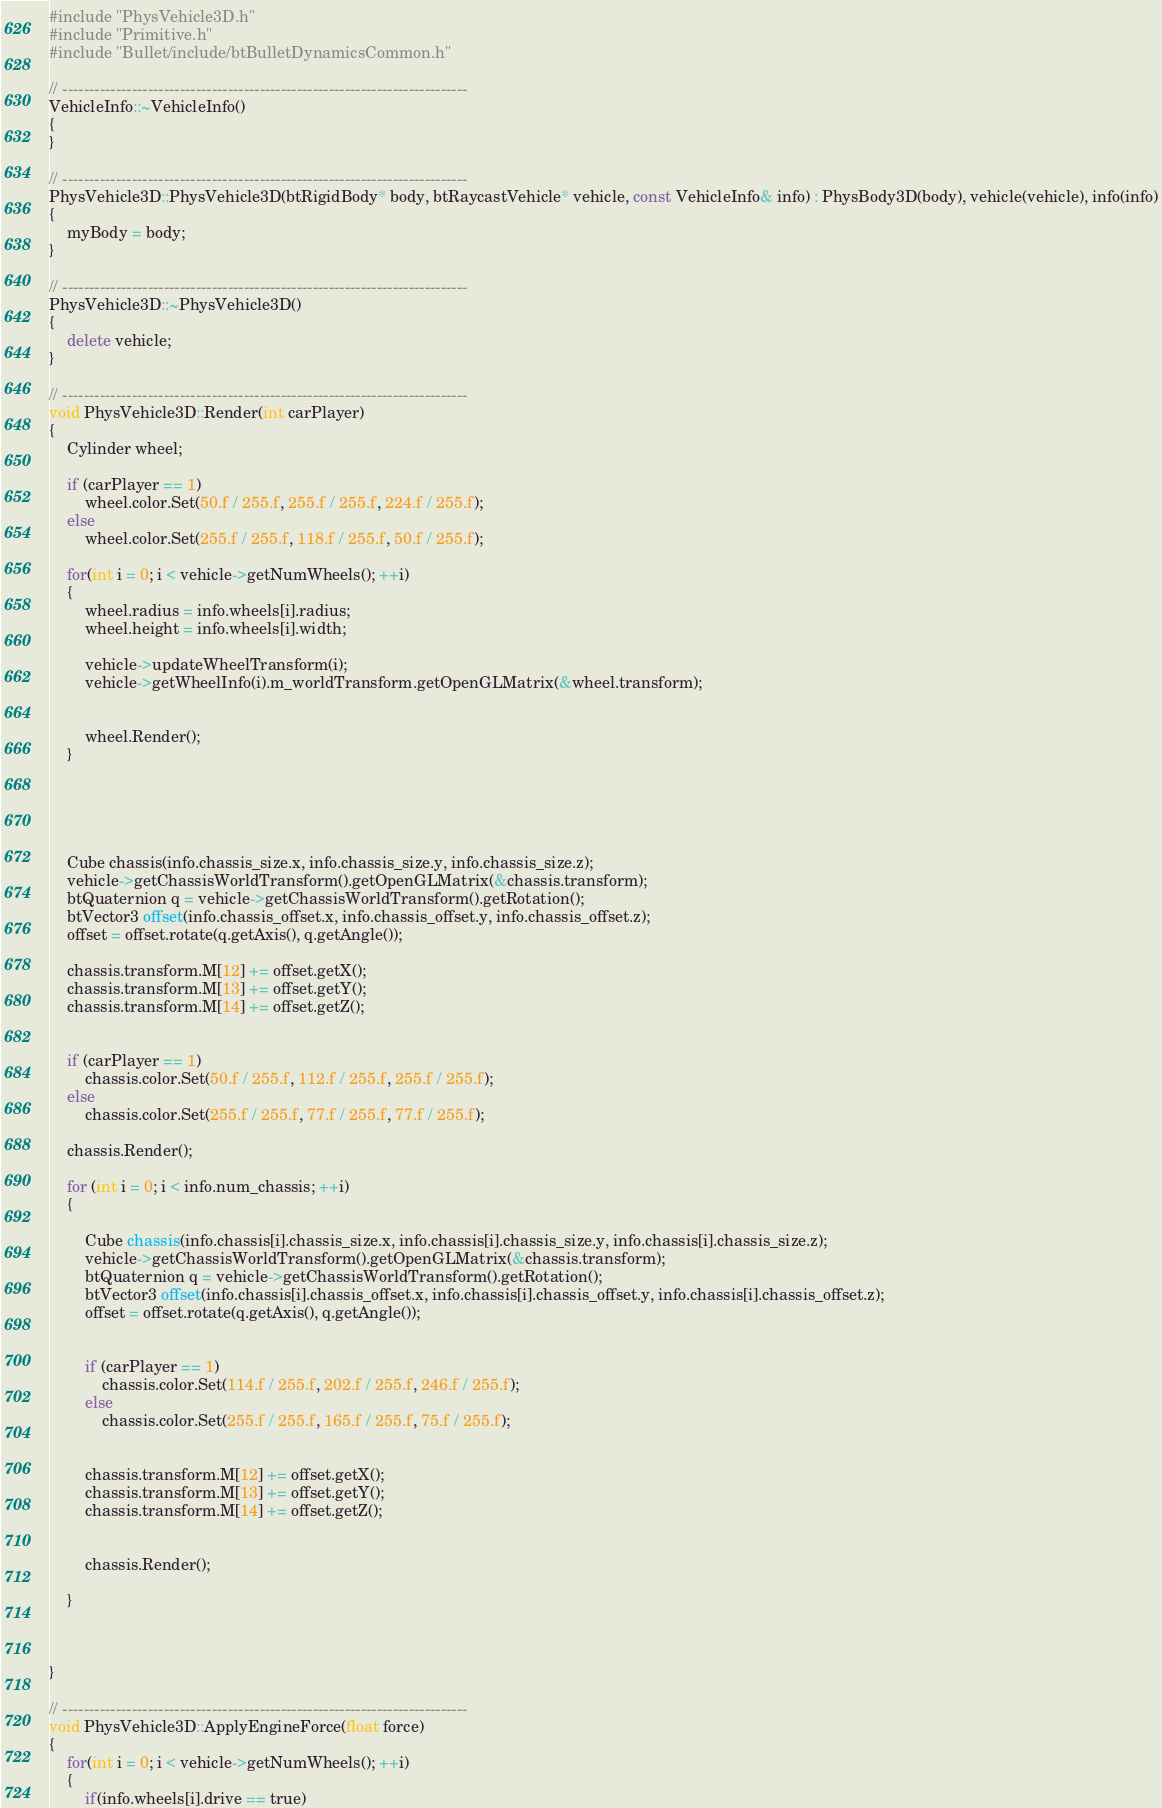Convert code to text. <code><loc_0><loc_0><loc_500><loc_500><_C++_>#include "PhysVehicle3D.h"
#include "Primitive.h"
#include "Bullet/include/btBulletDynamicsCommon.h"

// ----------------------------------------------------------------------------
VehicleInfo::~VehicleInfo()
{	
}

// ----------------------------------------------------------------------------
PhysVehicle3D::PhysVehicle3D(btRigidBody* body, btRaycastVehicle* vehicle, const VehicleInfo& info) : PhysBody3D(body), vehicle(vehicle), info(info)
{
	myBody = body;
}

// ----------------------------------------------------------------------------
PhysVehicle3D::~PhysVehicle3D()
{
	delete vehicle;
}

// ----------------------------------------------------------------------------
void PhysVehicle3D::Render(int carPlayer)
{
	Cylinder wheel;

	if (carPlayer == 1)
		wheel.color.Set(50.f / 255.f, 255.f / 255.f, 224.f / 255.f);
	else
		wheel.color.Set(255.f / 255.f, 118.f / 255.f, 50.f / 255.f);

	for(int i = 0; i < vehicle->getNumWheels(); ++i)
	{
		wheel.radius = info.wheels[i].radius;
		wheel.height = info.wheels[i].width;

		vehicle->updateWheelTransform(i);
		vehicle->getWheelInfo(i).m_worldTransform.getOpenGLMatrix(&wheel.transform);
		
		
		wheel.Render();
	}



		

	Cube chassis(info.chassis_size.x, info.chassis_size.y, info.chassis_size.z);
	vehicle->getChassisWorldTransform().getOpenGLMatrix(&chassis.transform);
	btQuaternion q = vehicle->getChassisWorldTransform().getRotation();
	btVector3 offset(info.chassis_offset.x, info.chassis_offset.y, info.chassis_offset.z);
	offset = offset.rotate(q.getAxis(), q.getAngle());

	chassis.transform.M[12] += offset.getX();
	chassis.transform.M[13] += offset.getY();
	chassis.transform.M[14] += offset.getZ();


	if (carPlayer == 1)
		chassis.color.Set(50.f / 255.f, 112.f / 255.f, 255.f / 255.f);
	else
		chassis.color.Set(255.f / 255.f, 77.f / 255.f, 77.f / 255.f);

	chassis.Render();

	for (int i = 0; i < info.num_chassis; ++i)
	{

		Cube chassis(info.chassis[i].chassis_size.x, info.chassis[i].chassis_size.y, info.chassis[i].chassis_size.z);
		vehicle->getChassisWorldTransform().getOpenGLMatrix(&chassis.transform);
		btQuaternion q = vehicle->getChassisWorldTransform().getRotation();
		btVector3 offset(info.chassis[i].chassis_offset.x, info.chassis[i].chassis_offset.y, info.chassis[i].chassis_offset.z);
		offset = offset.rotate(q.getAxis(), q.getAngle());


		if (carPlayer == 1)
			chassis.color.Set(114.f / 255.f, 202.f / 255.f, 246.f / 255.f);
		else
			chassis.color.Set(255.f / 255.f, 165.f / 255.f, 75.f / 255.f);
		

		chassis.transform.M[12] += offset.getX();
		chassis.transform.M[13] += offset.getY();
		chassis.transform.M[14] += offset.getZ();

	
		chassis.Render();

	}



}

// ----------------------------------------------------------------------------
void PhysVehicle3D::ApplyEngineForce(float force)
{
	for(int i = 0; i < vehicle->getNumWheels(); ++i)
	{
		if(info.wheels[i].drive == true)</code> 